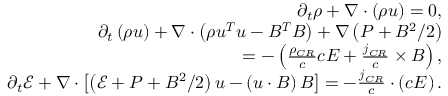Convert formula to latex. <formula><loc_0><loc_0><loc_500><loc_500>\begin{array} { r } { \partial _ { t } \rho + \nabla \cdot \left ( \rho u \right ) = 0 , } \\ { \partial _ { t } \left ( \rho u \right ) + \nabla \cdot \left ( \rho u ^ { T } u - B ^ { T } B \right ) + \nabla \left ( P + B ^ { 2 } / 2 \right ) } \\ { = - \left ( \frac { \rho _ { C R } } { c } c E + \frac { j _ { C R } } { c } \times B \right ) , } \\ { \partial _ { t } \mathcal { E } + \nabla \cdot \left [ \left ( \mathcal { E } + P + B ^ { 2 } / 2 \right ) u - \left ( u \cdot B \right ) B \right ] = - \frac { j _ { C R } } { c } \cdot \left ( c E \right ) . } \end{array}</formula> 